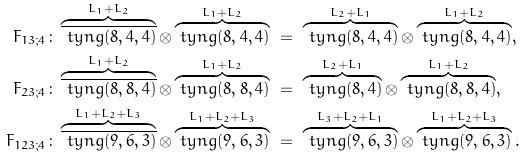Convert formula to latex. <formula><loc_0><loc_0><loc_500><loc_500>F _ { 1 3 ; 4 } \colon & \overbrace { \overline { \ t y n g ( 8 , 4 , 4 ) } } ^ { L _ { 1 } + L _ { 2 } } \otimes \overbrace { \ t y n g ( 8 , 4 , 4 ) } ^ { L _ { 1 } + L _ { 2 } } \ = \ \overbrace { \ t y n g ( 8 , 4 , 4 ) } ^ { L _ { 2 } + L _ { 1 } } \otimes \overbrace { \ t y n g ( 8 , 4 , 4 ) } ^ { L _ { 1 } + L _ { 2 } } , \\ F _ { 2 3 ; 4 } \colon & \overbrace { \overline { \ t y n g ( 8 , 8 , 4 ) } } ^ { L _ { 1 } + L _ { 2 } } \otimes \overbrace { \ t y n g ( 8 , 8 , 4 ) } ^ { L _ { 1 } + L _ { 2 } } \ = \ \overbrace { \ t y n g ( 8 , 4 ) } ^ { L _ { 2 } + L _ { 1 } } \otimes \overbrace { \ t y n g ( 8 , 8 , 4 ) } ^ { L _ { 1 } + L _ { 2 } } , \\ F _ { 1 2 3 ; 4 } \colon & \overbrace { \overline { \ t y n g ( 9 , 6 , 3 ) } } ^ { L _ { 1 } + L _ { 2 } + L _ { 3 } } \otimes \overbrace { \ t y n g ( 9 , 6 , 3 ) } ^ { L _ { 1 } + L _ { 2 } + L _ { 3 } } \ = \ \overbrace { \ t y n g ( 9 , 6 , 3 ) } ^ { L _ { 3 } + L _ { 2 } + L _ { 1 } } \otimes \overbrace { \ t y n g ( 9 , 6 , 3 ) } ^ { L _ { 1 } + L _ { 2 } + L _ { 3 } } .</formula> 